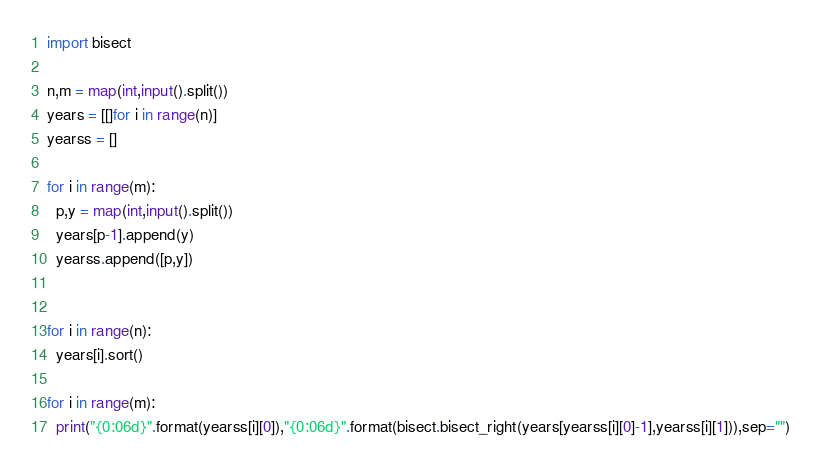<code> <loc_0><loc_0><loc_500><loc_500><_Python_>import bisect

n,m = map(int,input().split())
years = [[]for i in range(n)]
yearss = []

for i in range(m):
  p,y = map(int,input().split())
  years[p-1].append(y)
  yearss.append([p,y])


for i in range(n):
  years[i].sort()

for i in range(m):
  print("{0:06d}".format(yearss[i][0]),"{0:06d}".format(bisect.bisect_right(years[yearss[i][0]-1],yearss[i][1])),sep="")
</code> 